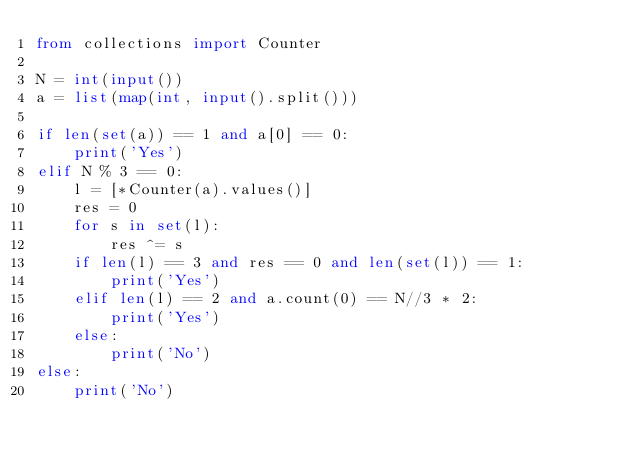Convert code to text. <code><loc_0><loc_0><loc_500><loc_500><_Python_>from collections import Counter

N = int(input())
a = list(map(int, input().split()))

if len(set(a)) == 1 and a[0] == 0:
    print('Yes')
elif N % 3 == 0:
    l = [*Counter(a).values()]
    res = 0
    for s in set(l):
        res ^= s
    if len(l) == 3 and res == 0 and len(set(l)) == 1:
        print('Yes')
    elif len(l) == 2 and a.count(0) == N//3 * 2:
        print('Yes')
    else:
        print('No')
else:
    print('No')</code> 